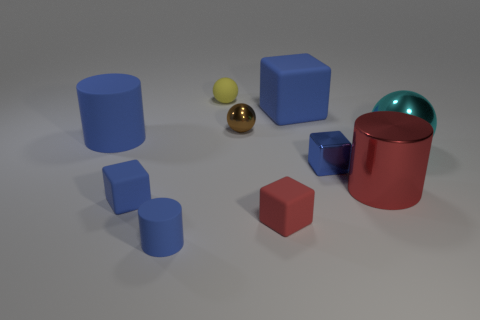What time of day does the lighting in this scene suggest? The lighting in the scene does not strongly suggest any particular time of day, as it appears to be a controlled, indoor environment with neutral, studio-like lighting. 